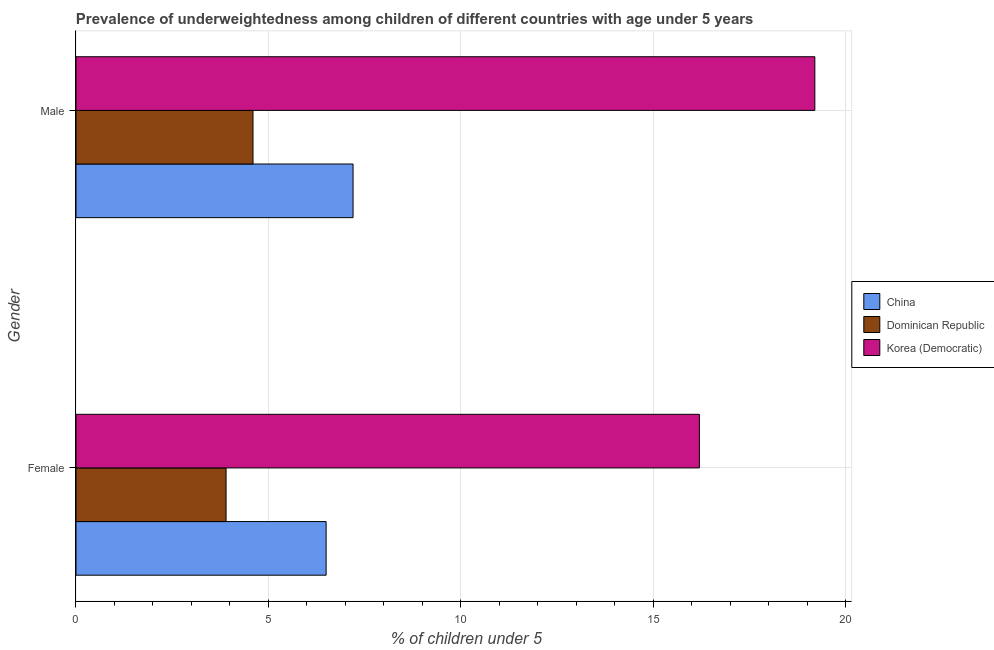How many groups of bars are there?
Offer a terse response. 2. Are the number of bars on each tick of the Y-axis equal?
Your response must be concise. Yes. How many bars are there on the 1st tick from the top?
Your answer should be very brief. 3. What is the percentage of underweighted male children in Korea (Democratic)?
Keep it short and to the point. 19.2. Across all countries, what is the maximum percentage of underweighted male children?
Provide a short and direct response. 19.2. Across all countries, what is the minimum percentage of underweighted female children?
Offer a very short reply. 3.9. In which country was the percentage of underweighted male children maximum?
Your answer should be compact. Korea (Democratic). In which country was the percentage of underweighted female children minimum?
Offer a terse response. Dominican Republic. What is the total percentage of underweighted male children in the graph?
Your response must be concise. 31. What is the difference between the percentage of underweighted female children in Korea (Democratic) and that in China?
Make the answer very short. 9.7. What is the difference between the percentage of underweighted female children in China and the percentage of underweighted male children in Korea (Democratic)?
Provide a succinct answer. -12.7. What is the average percentage of underweighted male children per country?
Keep it short and to the point. 10.33. What is the difference between the percentage of underweighted male children and percentage of underweighted female children in Dominican Republic?
Ensure brevity in your answer.  0.7. In how many countries, is the percentage of underweighted male children greater than 16 %?
Make the answer very short. 1. What is the ratio of the percentage of underweighted female children in China to that in Korea (Democratic)?
Provide a succinct answer. 0.4. Is the percentage of underweighted female children in Dominican Republic less than that in China?
Keep it short and to the point. Yes. What does the 2nd bar from the bottom in Male represents?
Your response must be concise. Dominican Republic. How many bars are there?
Keep it short and to the point. 6. Are all the bars in the graph horizontal?
Provide a short and direct response. Yes. Does the graph contain any zero values?
Give a very brief answer. No. How many legend labels are there?
Offer a terse response. 3. What is the title of the graph?
Give a very brief answer. Prevalence of underweightedness among children of different countries with age under 5 years. Does "Philippines" appear as one of the legend labels in the graph?
Offer a very short reply. No. What is the label or title of the X-axis?
Offer a very short reply.  % of children under 5. What is the label or title of the Y-axis?
Your response must be concise. Gender. What is the  % of children under 5 of Dominican Republic in Female?
Your answer should be compact. 3.9. What is the  % of children under 5 in Korea (Democratic) in Female?
Keep it short and to the point. 16.2. What is the  % of children under 5 in China in Male?
Ensure brevity in your answer.  7.2. What is the  % of children under 5 of Dominican Republic in Male?
Your response must be concise. 4.6. What is the  % of children under 5 of Korea (Democratic) in Male?
Provide a short and direct response. 19.2. Across all Gender, what is the maximum  % of children under 5 of China?
Keep it short and to the point. 7.2. Across all Gender, what is the maximum  % of children under 5 of Dominican Republic?
Give a very brief answer. 4.6. Across all Gender, what is the maximum  % of children under 5 of Korea (Democratic)?
Your response must be concise. 19.2. Across all Gender, what is the minimum  % of children under 5 of Dominican Republic?
Give a very brief answer. 3.9. Across all Gender, what is the minimum  % of children under 5 in Korea (Democratic)?
Keep it short and to the point. 16.2. What is the total  % of children under 5 of Korea (Democratic) in the graph?
Keep it short and to the point. 35.4. What is the difference between the  % of children under 5 in China in Female and that in Male?
Provide a succinct answer. -0.7. What is the difference between the  % of children under 5 of Dominican Republic in Female and that in Male?
Provide a succinct answer. -0.7. What is the difference between the  % of children under 5 of Korea (Democratic) in Female and that in Male?
Ensure brevity in your answer.  -3. What is the difference between the  % of children under 5 in China in Female and the  % of children under 5 in Dominican Republic in Male?
Make the answer very short. 1.9. What is the difference between the  % of children under 5 in Dominican Republic in Female and the  % of children under 5 in Korea (Democratic) in Male?
Your response must be concise. -15.3. What is the average  % of children under 5 of China per Gender?
Provide a short and direct response. 6.85. What is the average  % of children under 5 of Dominican Republic per Gender?
Offer a very short reply. 4.25. What is the difference between the  % of children under 5 in China and  % of children under 5 in Korea (Democratic) in Female?
Offer a terse response. -9.7. What is the difference between the  % of children under 5 in Dominican Republic and  % of children under 5 in Korea (Democratic) in Female?
Your response must be concise. -12.3. What is the difference between the  % of children under 5 in China and  % of children under 5 in Korea (Democratic) in Male?
Ensure brevity in your answer.  -12. What is the difference between the  % of children under 5 of Dominican Republic and  % of children under 5 of Korea (Democratic) in Male?
Provide a succinct answer. -14.6. What is the ratio of the  % of children under 5 of China in Female to that in Male?
Keep it short and to the point. 0.9. What is the ratio of the  % of children under 5 of Dominican Republic in Female to that in Male?
Your answer should be very brief. 0.85. What is the ratio of the  % of children under 5 in Korea (Democratic) in Female to that in Male?
Make the answer very short. 0.84. What is the difference between the highest and the lowest  % of children under 5 of China?
Give a very brief answer. 0.7. What is the difference between the highest and the lowest  % of children under 5 in Dominican Republic?
Your answer should be very brief. 0.7. What is the difference between the highest and the lowest  % of children under 5 in Korea (Democratic)?
Offer a very short reply. 3. 